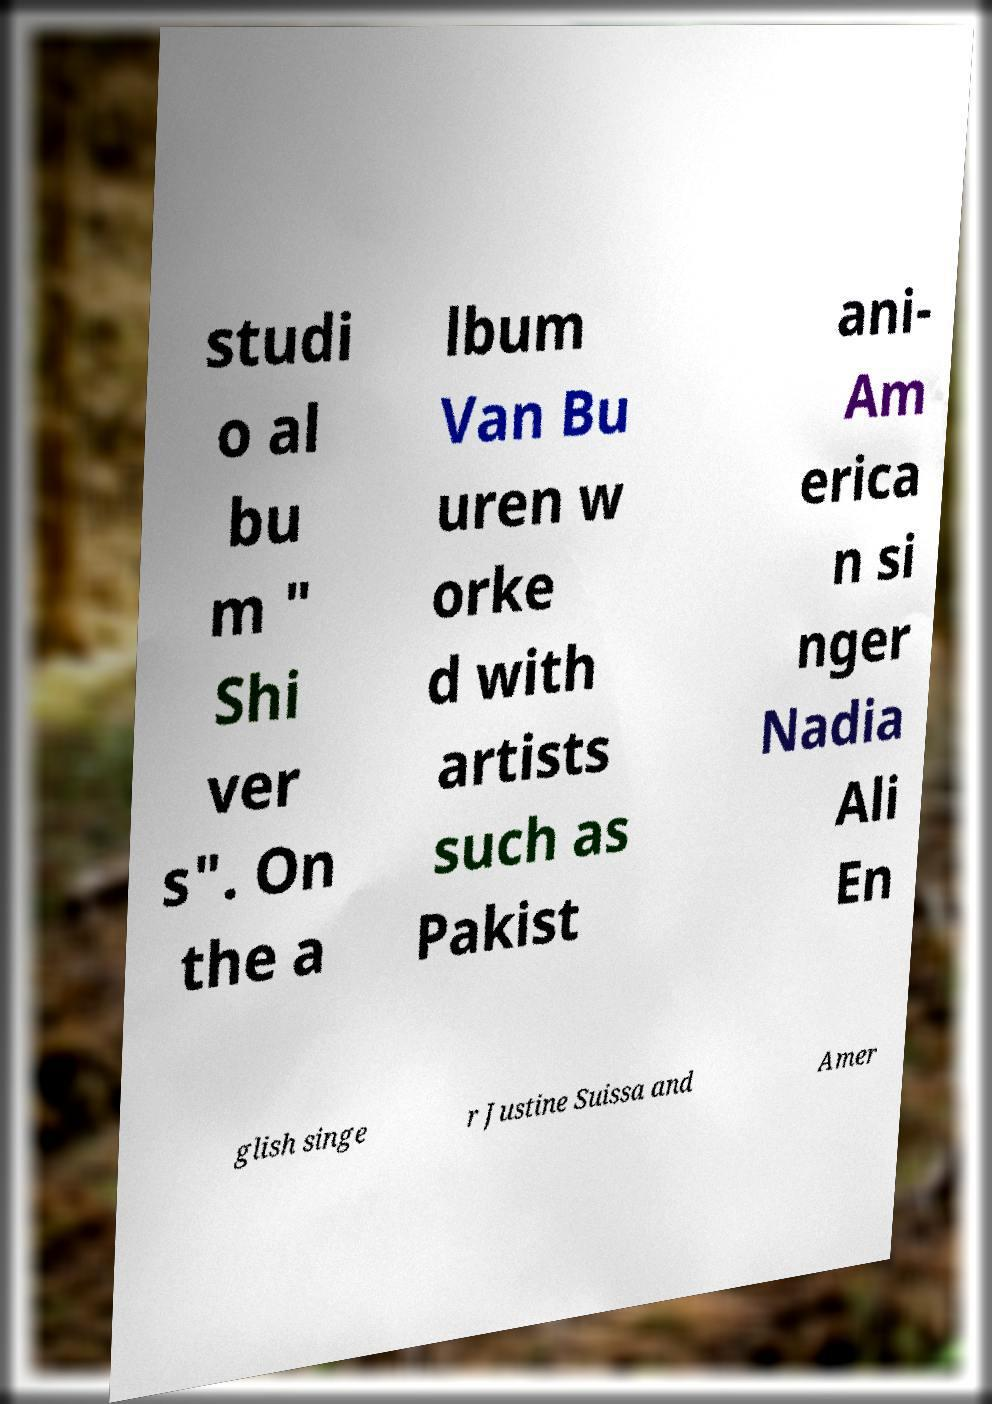What messages or text are displayed in this image? I need them in a readable, typed format. studi o al bu m " Shi ver s". On the a lbum Van Bu uren w orke d with artists such as Pakist ani- Am erica n si nger Nadia Ali En glish singe r Justine Suissa and Amer 